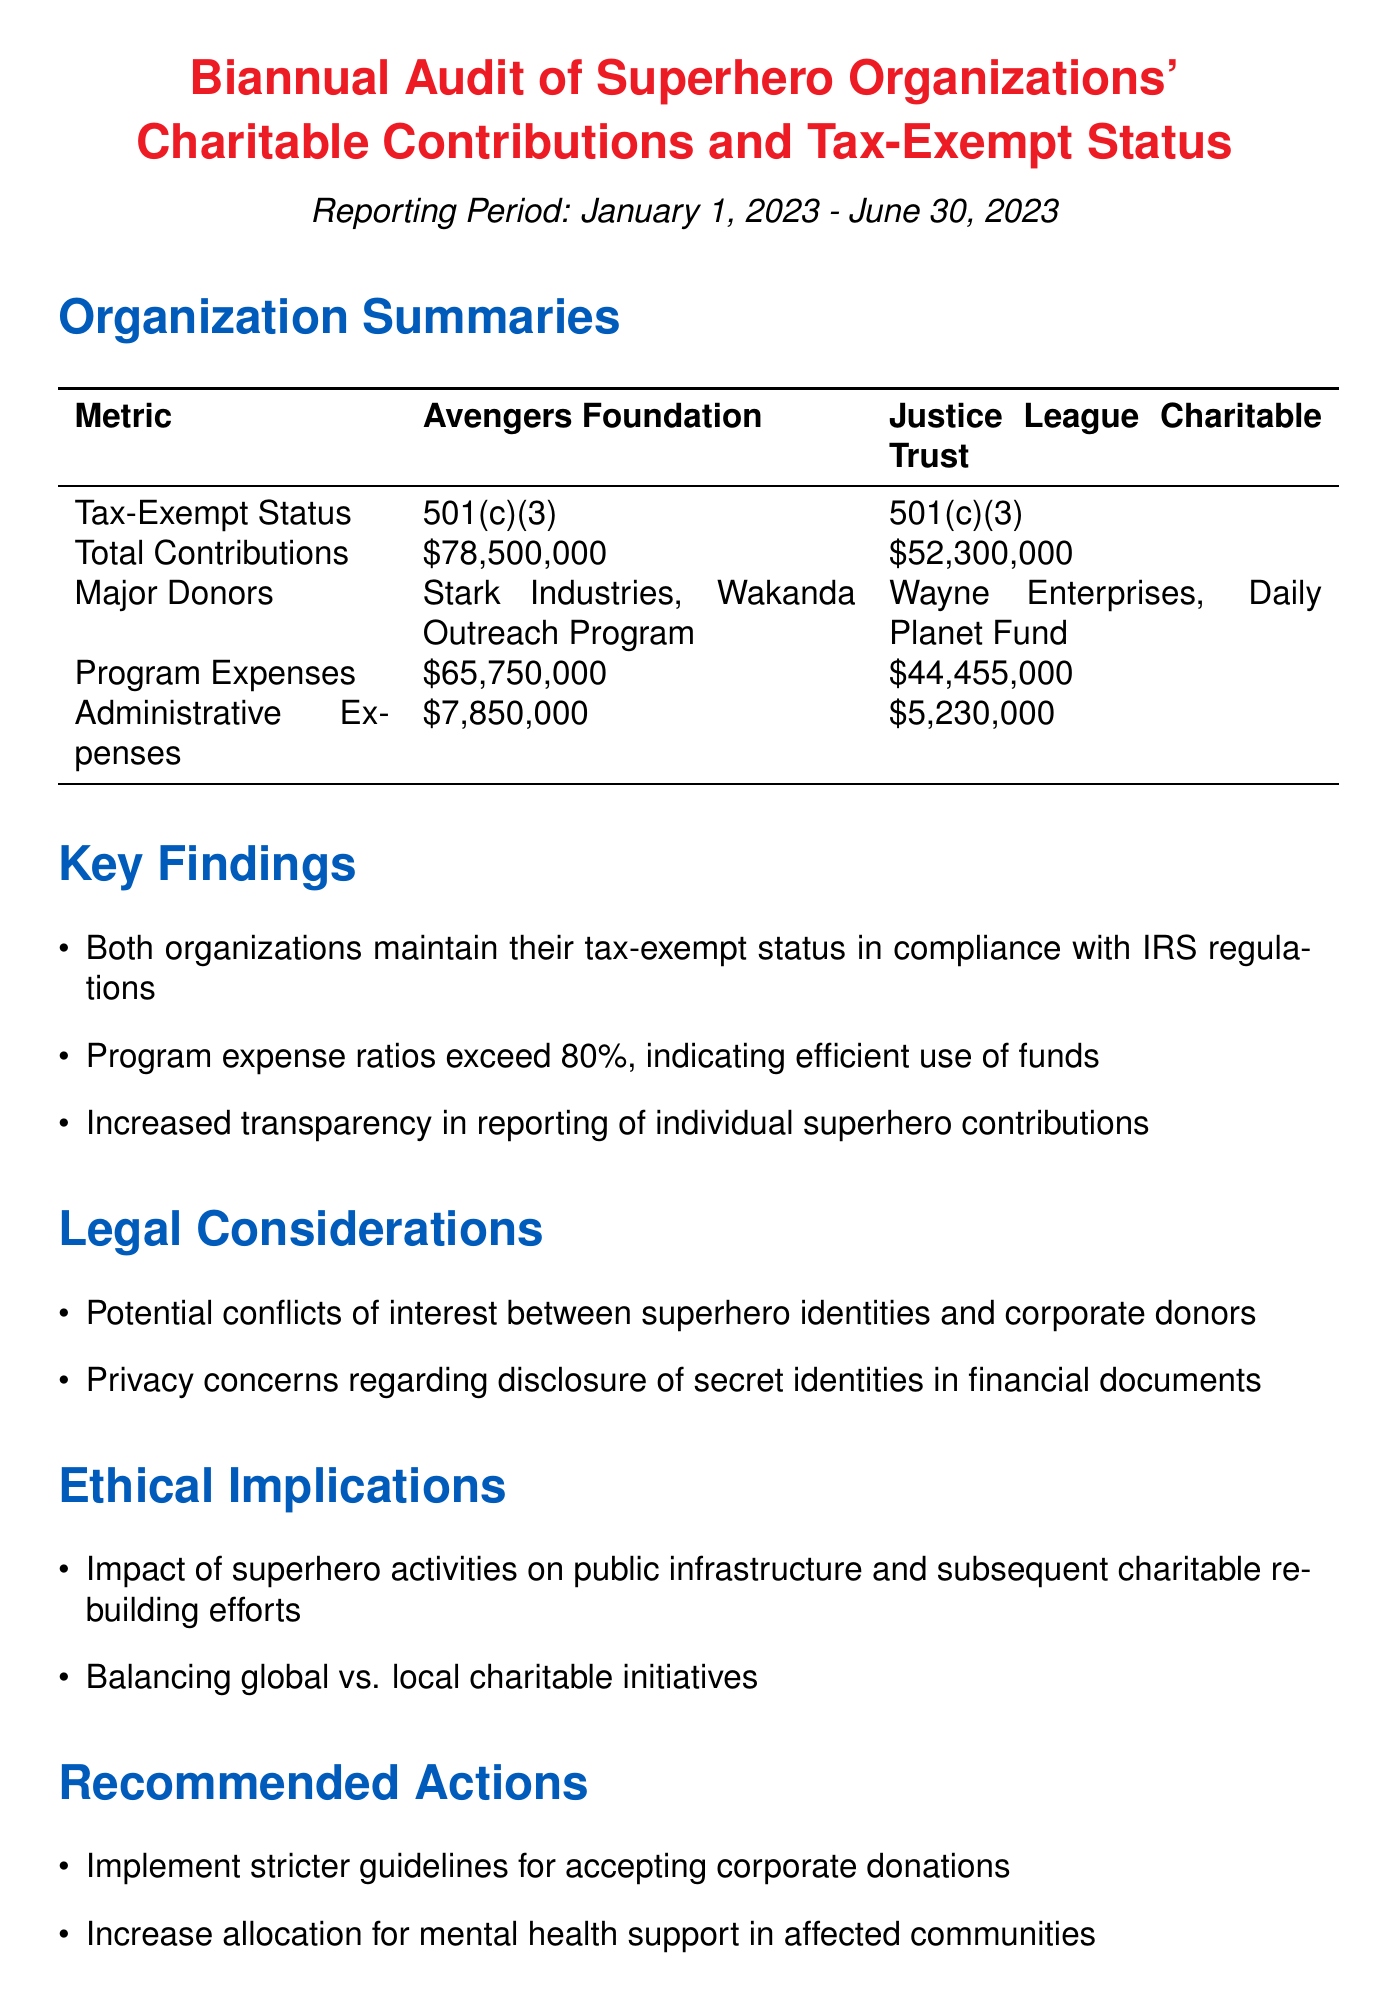What is the total contribution of the Avengers Foundation? The total contribution is explicitly mentioned in the document as the total contributions made by the Avengers Foundation, which is $78,500,000.
Answer: $78,500,000 What is the tax-exempt status of the Justice League Charitable Trust? The tax-exempt status is provided in the organization summaries section, where it states the status for the Justice League Charitable Trust as 501(c)(3).
Answer: 501(c)(3) How much did the Avengers Foundation spend on program expenses? The document specifies the program expenses of the Avengers Foundation, listed as $65,750,000.
Answer: $65,750,000 What percentage of program expenses is considered efficient use of funds? The key findings section mentions that program expense ratios exceed 80%, indicating this level as efficient use of funds.
Answer: 80% What are one of the legal considerations mentioned in the report? The report includes legal considerations, such as potential conflicts of interest between superhero identities and corporate donors.
Answer: Potential conflicts of interest What is one of the recommended actions for superhero organizations? The recommended actions suggest implementing stricter guidelines for accepting corporate donations as a measure towards better governance in donations.
Answer: Stricter guidelines for accepting corporate donations What is the reporting period covered in the audit? The reporting period is stated in the document, which is from January 1, 2023 to June 30, 2023.
Answer: January 1, 2023 - June 30, 2023 How much funding was reported for administrative expenses by the Justice League Charitable Trust? The document details the administrative expenses for the Justice League Charitable Trust, quantifying it as $5,230,000.
Answer: $5,230,000 